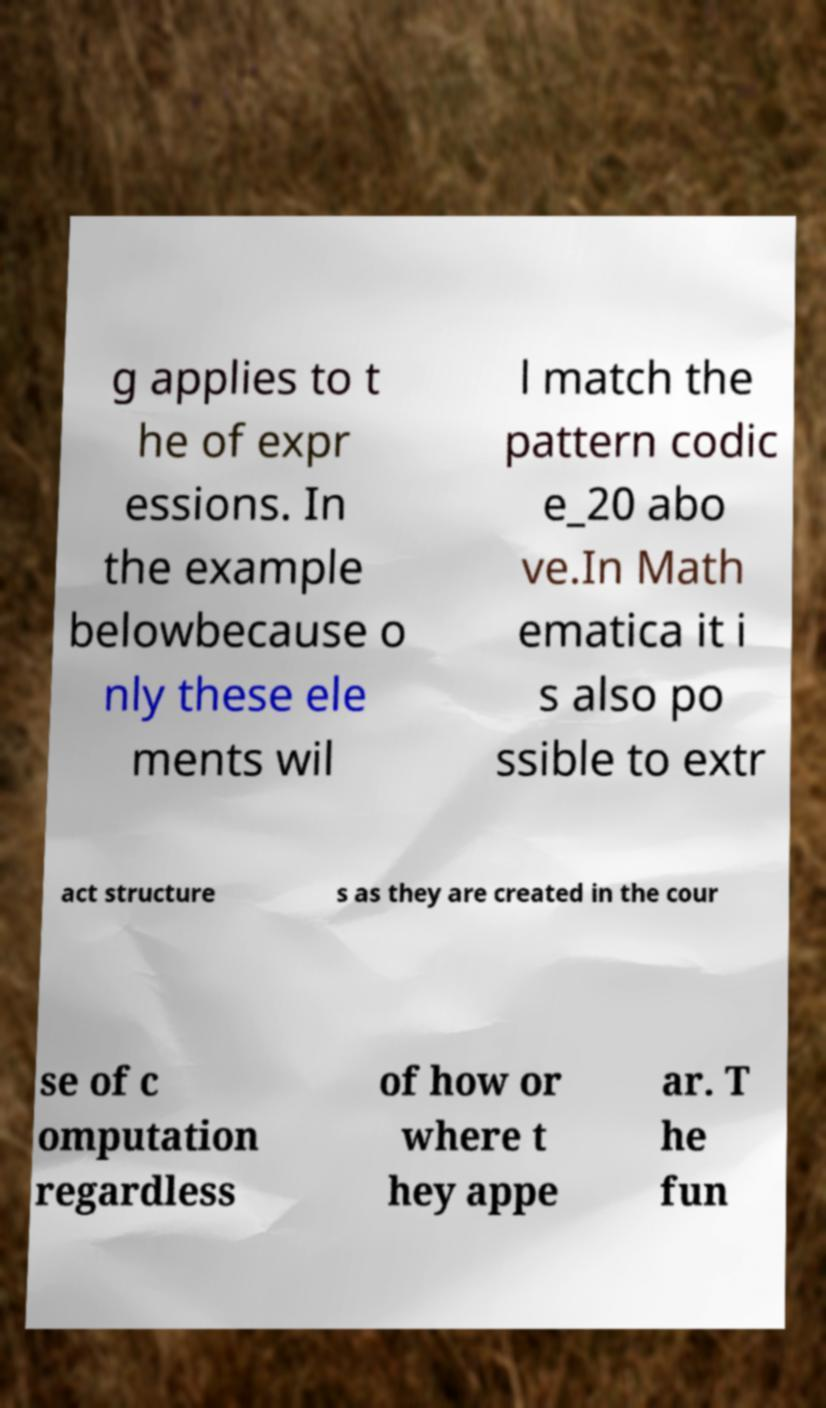Could you assist in decoding the text presented in this image and type it out clearly? g applies to t he of expr essions. In the example belowbecause o nly these ele ments wil l match the pattern codic e_20 abo ve.In Math ematica it i s also po ssible to extr act structure s as they are created in the cour se of c omputation regardless of how or where t hey appe ar. T he fun 